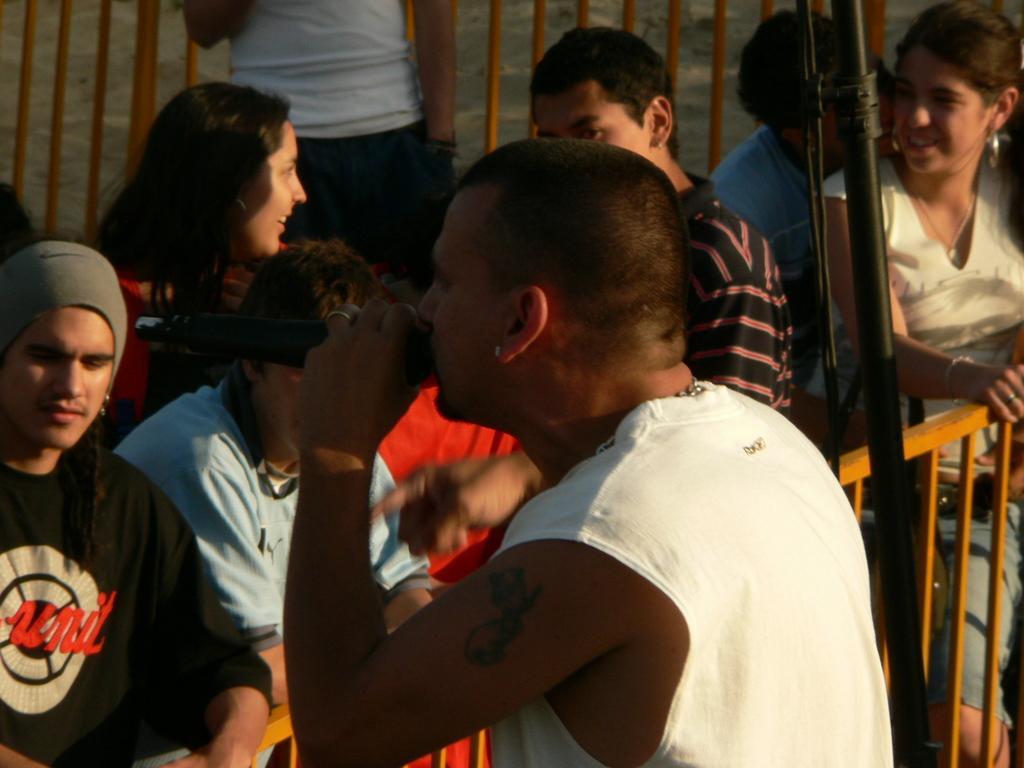Please provide a concise description of this image. This image consists of many people. In the front, we can see a man wearing a white T-shirt is singing in a mic. In the background, there are many people standing. In the middle, there is a fencing. 